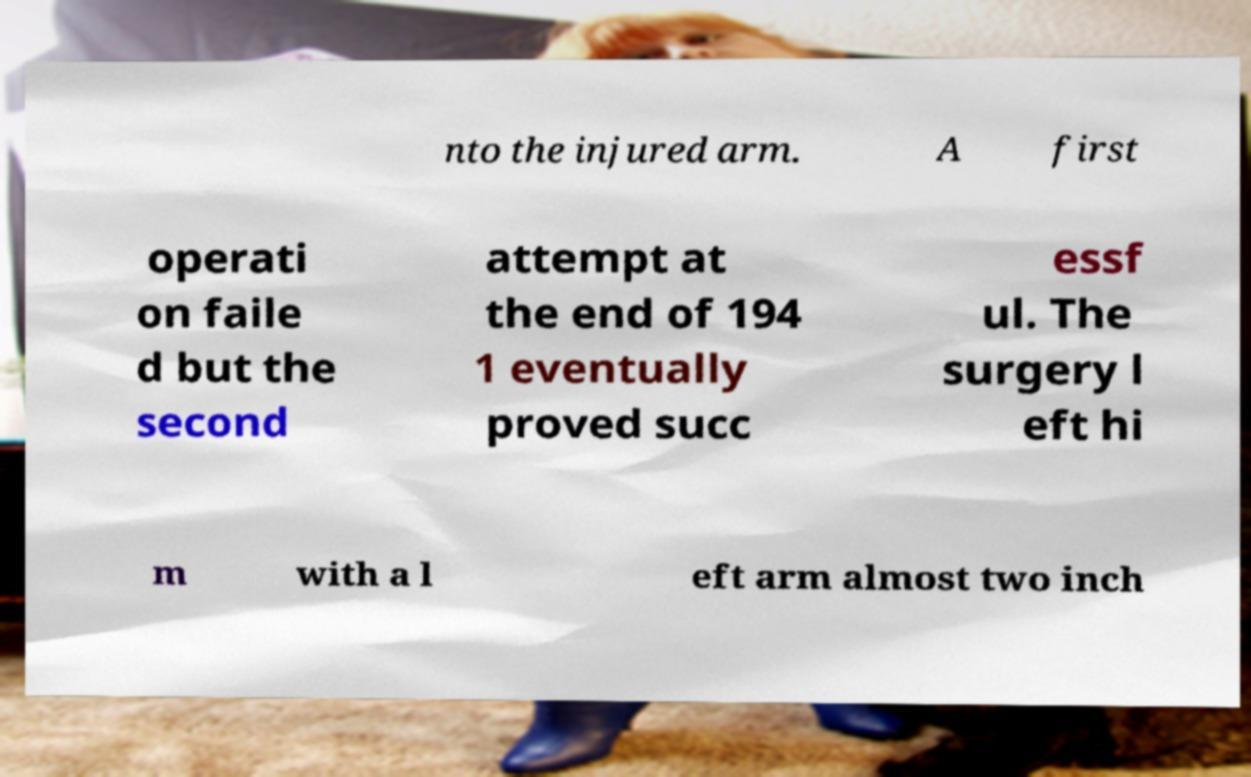I need the written content from this picture converted into text. Can you do that? nto the injured arm. A first operati on faile d but the second attempt at the end of 194 1 eventually proved succ essf ul. The surgery l eft hi m with a l eft arm almost two inch 